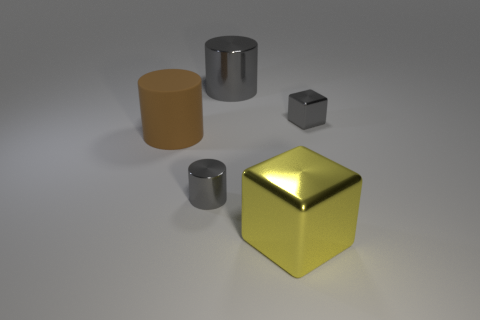Subtract all tiny gray cylinders. How many cylinders are left? 2 Add 4 big gray metal cubes. How many objects exist? 9 Subtract all brown blocks. How many gray cylinders are left? 2 Subtract all yellow cubes. How many cubes are left? 1 Subtract all cubes. How many objects are left? 3 Subtract 3 cylinders. How many cylinders are left? 0 Subtract all big cyan things. Subtract all large gray shiny things. How many objects are left? 4 Add 5 large shiny objects. How many large shiny objects are left? 7 Add 2 yellow metallic objects. How many yellow metallic objects exist? 3 Subtract 0 red blocks. How many objects are left? 5 